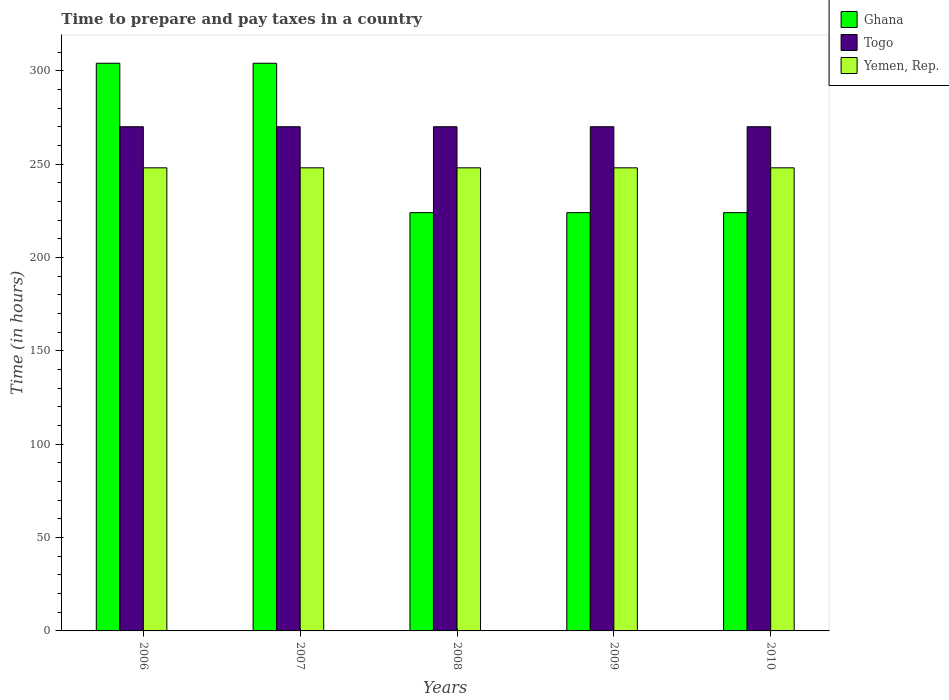How many different coloured bars are there?
Offer a very short reply. 3. How many groups of bars are there?
Provide a short and direct response. 5. Are the number of bars per tick equal to the number of legend labels?
Provide a succinct answer. Yes. What is the number of hours required to prepare and pay taxes in Togo in 2006?
Offer a very short reply. 270. Across all years, what is the maximum number of hours required to prepare and pay taxes in Ghana?
Offer a terse response. 304. Across all years, what is the minimum number of hours required to prepare and pay taxes in Togo?
Make the answer very short. 270. In which year was the number of hours required to prepare and pay taxes in Ghana maximum?
Your answer should be very brief. 2006. In which year was the number of hours required to prepare and pay taxes in Yemen, Rep. minimum?
Keep it short and to the point. 2006. What is the total number of hours required to prepare and pay taxes in Togo in the graph?
Ensure brevity in your answer.  1350. What is the difference between the number of hours required to prepare and pay taxes in Yemen, Rep. in 2009 and the number of hours required to prepare and pay taxes in Togo in 2006?
Provide a short and direct response. -22. What is the average number of hours required to prepare and pay taxes in Ghana per year?
Keep it short and to the point. 256. In the year 2008, what is the difference between the number of hours required to prepare and pay taxes in Ghana and number of hours required to prepare and pay taxes in Yemen, Rep.?
Offer a very short reply. -24. What is the ratio of the number of hours required to prepare and pay taxes in Ghana in 2007 to that in 2008?
Ensure brevity in your answer.  1.36. Is the number of hours required to prepare and pay taxes in Togo in 2007 less than that in 2008?
Keep it short and to the point. No. Is the difference between the number of hours required to prepare and pay taxes in Ghana in 2007 and 2009 greater than the difference between the number of hours required to prepare and pay taxes in Yemen, Rep. in 2007 and 2009?
Your answer should be compact. Yes. What is the difference between the highest and the second highest number of hours required to prepare and pay taxes in Ghana?
Your answer should be compact. 0. What is the difference between the highest and the lowest number of hours required to prepare and pay taxes in Ghana?
Ensure brevity in your answer.  80. In how many years, is the number of hours required to prepare and pay taxes in Togo greater than the average number of hours required to prepare and pay taxes in Togo taken over all years?
Make the answer very short. 0. Is the sum of the number of hours required to prepare and pay taxes in Yemen, Rep. in 2006 and 2007 greater than the maximum number of hours required to prepare and pay taxes in Ghana across all years?
Give a very brief answer. Yes. What does the 2nd bar from the left in 2007 represents?
Your answer should be very brief. Togo. What does the 2nd bar from the right in 2009 represents?
Provide a short and direct response. Togo. Is it the case that in every year, the sum of the number of hours required to prepare and pay taxes in Togo and number of hours required to prepare and pay taxes in Ghana is greater than the number of hours required to prepare and pay taxes in Yemen, Rep.?
Give a very brief answer. Yes. How many bars are there?
Make the answer very short. 15. Are all the bars in the graph horizontal?
Provide a short and direct response. No. How many years are there in the graph?
Give a very brief answer. 5. Are the values on the major ticks of Y-axis written in scientific E-notation?
Give a very brief answer. No. Does the graph contain any zero values?
Make the answer very short. No. How many legend labels are there?
Give a very brief answer. 3. How are the legend labels stacked?
Your response must be concise. Vertical. What is the title of the graph?
Ensure brevity in your answer.  Time to prepare and pay taxes in a country. What is the label or title of the Y-axis?
Provide a short and direct response. Time (in hours). What is the Time (in hours) in Ghana in 2006?
Your response must be concise. 304. What is the Time (in hours) of Togo in 2006?
Provide a short and direct response. 270. What is the Time (in hours) in Yemen, Rep. in 2006?
Your answer should be very brief. 248. What is the Time (in hours) of Ghana in 2007?
Ensure brevity in your answer.  304. What is the Time (in hours) in Togo in 2007?
Offer a terse response. 270. What is the Time (in hours) in Yemen, Rep. in 2007?
Offer a very short reply. 248. What is the Time (in hours) of Ghana in 2008?
Provide a succinct answer. 224. What is the Time (in hours) in Togo in 2008?
Your response must be concise. 270. What is the Time (in hours) of Yemen, Rep. in 2008?
Provide a short and direct response. 248. What is the Time (in hours) of Ghana in 2009?
Make the answer very short. 224. What is the Time (in hours) in Togo in 2009?
Give a very brief answer. 270. What is the Time (in hours) of Yemen, Rep. in 2009?
Provide a succinct answer. 248. What is the Time (in hours) of Ghana in 2010?
Ensure brevity in your answer.  224. What is the Time (in hours) in Togo in 2010?
Your answer should be compact. 270. What is the Time (in hours) of Yemen, Rep. in 2010?
Your answer should be compact. 248. Across all years, what is the maximum Time (in hours) in Ghana?
Provide a short and direct response. 304. Across all years, what is the maximum Time (in hours) in Togo?
Give a very brief answer. 270. Across all years, what is the maximum Time (in hours) in Yemen, Rep.?
Give a very brief answer. 248. Across all years, what is the minimum Time (in hours) in Ghana?
Offer a terse response. 224. Across all years, what is the minimum Time (in hours) of Togo?
Your answer should be very brief. 270. Across all years, what is the minimum Time (in hours) in Yemen, Rep.?
Make the answer very short. 248. What is the total Time (in hours) in Ghana in the graph?
Give a very brief answer. 1280. What is the total Time (in hours) in Togo in the graph?
Offer a terse response. 1350. What is the total Time (in hours) in Yemen, Rep. in the graph?
Your response must be concise. 1240. What is the difference between the Time (in hours) of Togo in 2006 and that in 2007?
Offer a very short reply. 0. What is the difference between the Time (in hours) of Yemen, Rep. in 2006 and that in 2007?
Give a very brief answer. 0. What is the difference between the Time (in hours) in Ghana in 2006 and that in 2008?
Provide a short and direct response. 80. What is the difference between the Time (in hours) in Togo in 2006 and that in 2008?
Provide a succinct answer. 0. What is the difference between the Time (in hours) in Ghana in 2006 and that in 2009?
Give a very brief answer. 80. What is the difference between the Time (in hours) of Yemen, Rep. in 2006 and that in 2009?
Provide a succinct answer. 0. What is the difference between the Time (in hours) in Ghana in 2006 and that in 2010?
Your answer should be compact. 80. What is the difference between the Time (in hours) in Togo in 2006 and that in 2010?
Your answer should be very brief. 0. What is the difference between the Time (in hours) in Yemen, Rep. in 2006 and that in 2010?
Keep it short and to the point. 0. What is the difference between the Time (in hours) in Ghana in 2007 and that in 2008?
Your answer should be very brief. 80. What is the difference between the Time (in hours) in Yemen, Rep. in 2007 and that in 2008?
Ensure brevity in your answer.  0. What is the difference between the Time (in hours) of Ghana in 2007 and that in 2009?
Give a very brief answer. 80. What is the difference between the Time (in hours) in Togo in 2007 and that in 2009?
Your response must be concise. 0. What is the difference between the Time (in hours) of Yemen, Rep. in 2007 and that in 2010?
Give a very brief answer. 0. What is the difference between the Time (in hours) of Ghana in 2008 and that in 2009?
Your response must be concise. 0. What is the difference between the Time (in hours) of Togo in 2008 and that in 2009?
Provide a short and direct response. 0. What is the difference between the Time (in hours) of Yemen, Rep. in 2008 and that in 2009?
Give a very brief answer. 0. What is the difference between the Time (in hours) of Yemen, Rep. in 2008 and that in 2010?
Offer a very short reply. 0. What is the difference between the Time (in hours) of Yemen, Rep. in 2009 and that in 2010?
Ensure brevity in your answer.  0. What is the difference between the Time (in hours) of Ghana in 2006 and the Time (in hours) of Togo in 2007?
Offer a very short reply. 34. What is the difference between the Time (in hours) in Ghana in 2006 and the Time (in hours) in Yemen, Rep. in 2007?
Keep it short and to the point. 56. What is the difference between the Time (in hours) of Togo in 2006 and the Time (in hours) of Yemen, Rep. in 2007?
Give a very brief answer. 22. What is the difference between the Time (in hours) of Ghana in 2006 and the Time (in hours) of Togo in 2008?
Your answer should be very brief. 34. What is the difference between the Time (in hours) of Ghana in 2006 and the Time (in hours) of Yemen, Rep. in 2008?
Your answer should be very brief. 56. What is the difference between the Time (in hours) in Togo in 2006 and the Time (in hours) in Yemen, Rep. in 2008?
Ensure brevity in your answer.  22. What is the difference between the Time (in hours) of Ghana in 2006 and the Time (in hours) of Yemen, Rep. in 2009?
Provide a short and direct response. 56. What is the difference between the Time (in hours) of Ghana in 2006 and the Time (in hours) of Togo in 2010?
Offer a very short reply. 34. What is the difference between the Time (in hours) of Ghana in 2006 and the Time (in hours) of Yemen, Rep. in 2010?
Keep it short and to the point. 56. What is the difference between the Time (in hours) in Ghana in 2007 and the Time (in hours) in Togo in 2008?
Your response must be concise. 34. What is the difference between the Time (in hours) in Ghana in 2007 and the Time (in hours) in Yemen, Rep. in 2008?
Your answer should be very brief. 56. What is the difference between the Time (in hours) of Togo in 2007 and the Time (in hours) of Yemen, Rep. in 2008?
Your answer should be compact. 22. What is the difference between the Time (in hours) in Ghana in 2007 and the Time (in hours) in Togo in 2009?
Your response must be concise. 34. What is the difference between the Time (in hours) in Ghana in 2007 and the Time (in hours) in Togo in 2010?
Keep it short and to the point. 34. What is the difference between the Time (in hours) in Togo in 2007 and the Time (in hours) in Yemen, Rep. in 2010?
Ensure brevity in your answer.  22. What is the difference between the Time (in hours) of Ghana in 2008 and the Time (in hours) of Togo in 2009?
Offer a very short reply. -46. What is the difference between the Time (in hours) of Togo in 2008 and the Time (in hours) of Yemen, Rep. in 2009?
Provide a short and direct response. 22. What is the difference between the Time (in hours) of Ghana in 2008 and the Time (in hours) of Togo in 2010?
Offer a very short reply. -46. What is the difference between the Time (in hours) in Ghana in 2009 and the Time (in hours) in Togo in 2010?
Make the answer very short. -46. What is the average Time (in hours) in Ghana per year?
Offer a terse response. 256. What is the average Time (in hours) of Togo per year?
Your answer should be very brief. 270. What is the average Time (in hours) in Yemen, Rep. per year?
Give a very brief answer. 248. In the year 2006, what is the difference between the Time (in hours) of Ghana and Time (in hours) of Togo?
Ensure brevity in your answer.  34. In the year 2006, what is the difference between the Time (in hours) of Togo and Time (in hours) of Yemen, Rep.?
Offer a terse response. 22. In the year 2008, what is the difference between the Time (in hours) of Ghana and Time (in hours) of Togo?
Your answer should be very brief. -46. In the year 2008, what is the difference between the Time (in hours) of Ghana and Time (in hours) of Yemen, Rep.?
Make the answer very short. -24. In the year 2009, what is the difference between the Time (in hours) in Ghana and Time (in hours) in Togo?
Your response must be concise. -46. In the year 2010, what is the difference between the Time (in hours) of Ghana and Time (in hours) of Togo?
Ensure brevity in your answer.  -46. In the year 2010, what is the difference between the Time (in hours) of Ghana and Time (in hours) of Yemen, Rep.?
Ensure brevity in your answer.  -24. What is the ratio of the Time (in hours) of Togo in 2006 to that in 2007?
Your response must be concise. 1. What is the ratio of the Time (in hours) of Yemen, Rep. in 2006 to that in 2007?
Provide a short and direct response. 1. What is the ratio of the Time (in hours) of Ghana in 2006 to that in 2008?
Offer a very short reply. 1.36. What is the ratio of the Time (in hours) in Yemen, Rep. in 2006 to that in 2008?
Provide a succinct answer. 1. What is the ratio of the Time (in hours) of Ghana in 2006 to that in 2009?
Offer a very short reply. 1.36. What is the ratio of the Time (in hours) of Ghana in 2006 to that in 2010?
Provide a short and direct response. 1.36. What is the ratio of the Time (in hours) of Togo in 2006 to that in 2010?
Make the answer very short. 1. What is the ratio of the Time (in hours) of Yemen, Rep. in 2006 to that in 2010?
Your response must be concise. 1. What is the ratio of the Time (in hours) in Ghana in 2007 to that in 2008?
Provide a succinct answer. 1.36. What is the ratio of the Time (in hours) in Togo in 2007 to that in 2008?
Your answer should be very brief. 1. What is the ratio of the Time (in hours) in Yemen, Rep. in 2007 to that in 2008?
Provide a succinct answer. 1. What is the ratio of the Time (in hours) in Ghana in 2007 to that in 2009?
Provide a short and direct response. 1.36. What is the ratio of the Time (in hours) of Togo in 2007 to that in 2009?
Make the answer very short. 1. What is the ratio of the Time (in hours) in Ghana in 2007 to that in 2010?
Give a very brief answer. 1.36. What is the ratio of the Time (in hours) in Togo in 2007 to that in 2010?
Offer a terse response. 1. What is the ratio of the Time (in hours) of Ghana in 2008 to that in 2009?
Provide a short and direct response. 1. What is the ratio of the Time (in hours) in Ghana in 2008 to that in 2010?
Provide a short and direct response. 1. What is the ratio of the Time (in hours) of Togo in 2008 to that in 2010?
Give a very brief answer. 1. What is the ratio of the Time (in hours) of Ghana in 2009 to that in 2010?
Keep it short and to the point. 1. What is the ratio of the Time (in hours) in Togo in 2009 to that in 2010?
Ensure brevity in your answer.  1. What is the difference between the highest and the second highest Time (in hours) in Togo?
Your answer should be very brief. 0. What is the difference between the highest and the second highest Time (in hours) in Yemen, Rep.?
Your answer should be compact. 0. What is the difference between the highest and the lowest Time (in hours) of Ghana?
Offer a terse response. 80. What is the difference between the highest and the lowest Time (in hours) of Togo?
Offer a very short reply. 0. What is the difference between the highest and the lowest Time (in hours) in Yemen, Rep.?
Give a very brief answer. 0. 